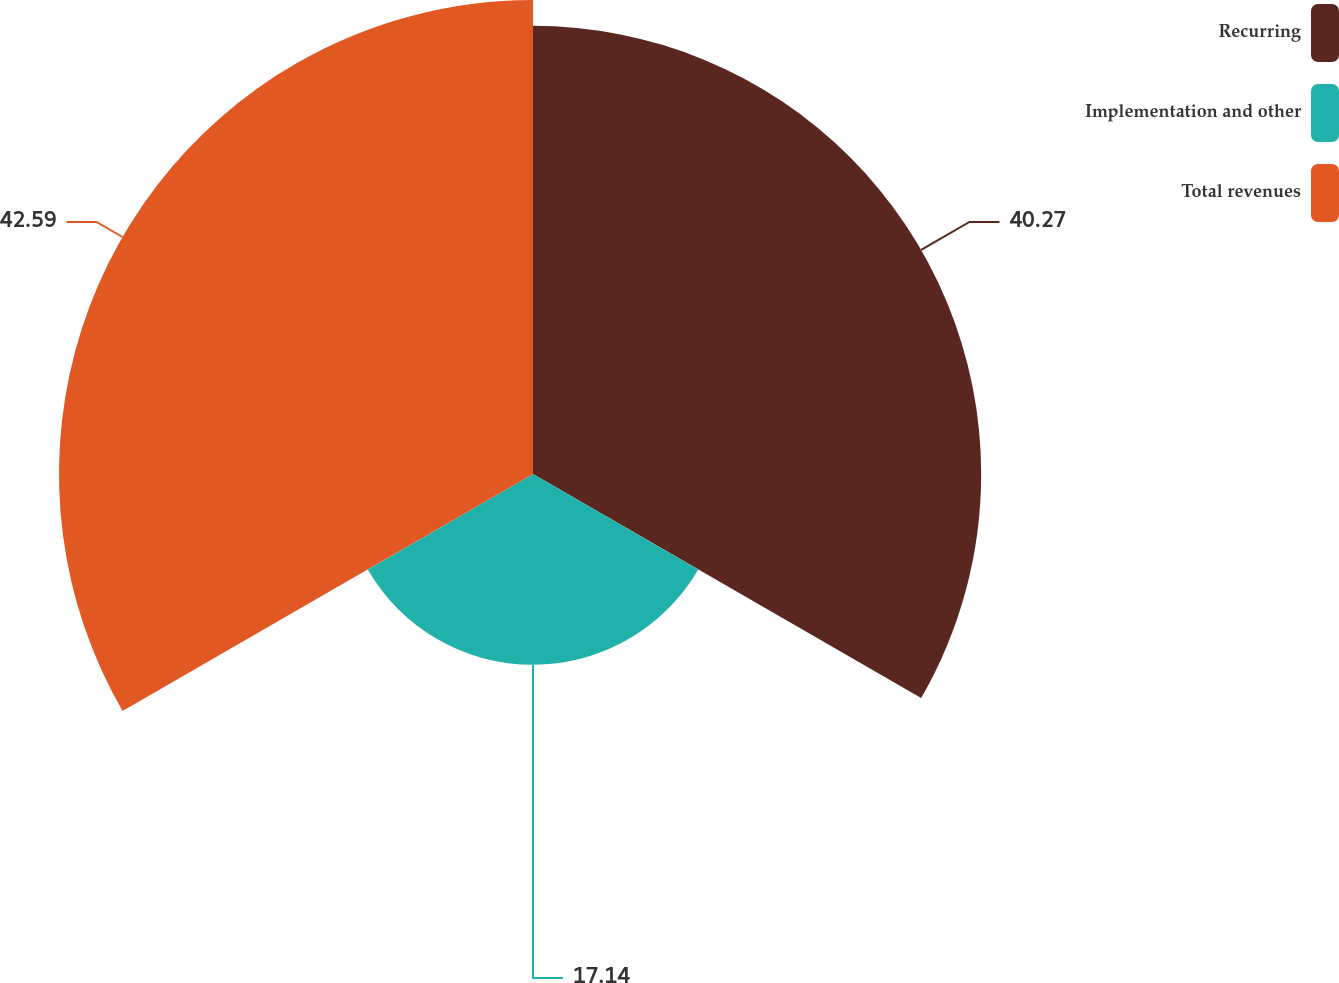Convert chart to OTSL. <chart><loc_0><loc_0><loc_500><loc_500><pie_chart><fcel>Recurring<fcel>Implementation and other<fcel>Total revenues<nl><fcel>40.27%<fcel>17.14%<fcel>42.59%<nl></chart> 